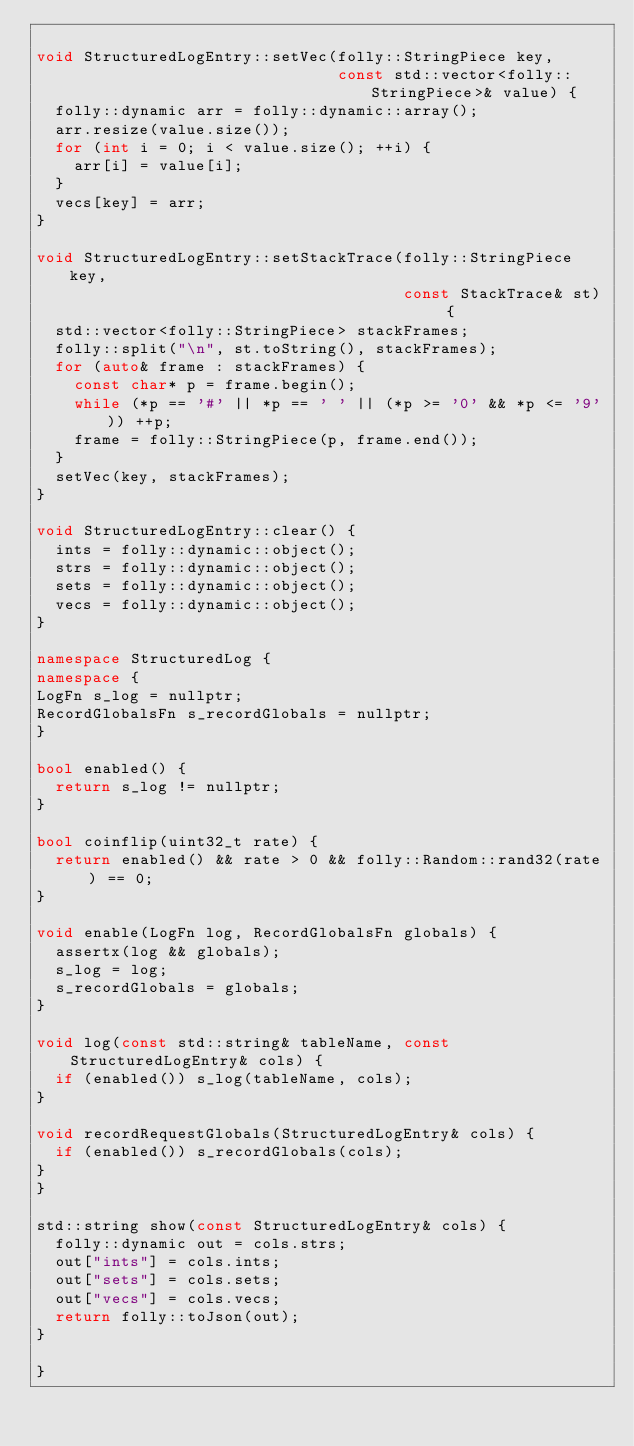<code> <loc_0><loc_0><loc_500><loc_500><_C++_>
void StructuredLogEntry::setVec(folly::StringPiece key,
                                const std::vector<folly::StringPiece>& value) {
  folly::dynamic arr = folly::dynamic::array();
  arr.resize(value.size());
  for (int i = 0; i < value.size(); ++i) {
    arr[i] = value[i];
  }
  vecs[key] = arr;
}

void StructuredLogEntry::setStackTrace(folly::StringPiece key,
                                       const StackTrace& st) {
  std::vector<folly::StringPiece> stackFrames;
  folly::split("\n", st.toString(), stackFrames);
  for (auto& frame : stackFrames) {
    const char* p = frame.begin();
    while (*p == '#' || *p == ' ' || (*p >= '0' && *p <= '9')) ++p;
    frame = folly::StringPiece(p, frame.end());
  }
  setVec(key, stackFrames);
}

void StructuredLogEntry::clear() {
  ints = folly::dynamic::object();
  strs = folly::dynamic::object();
  sets = folly::dynamic::object();
  vecs = folly::dynamic::object();
}

namespace StructuredLog {
namespace {
LogFn s_log = nullptr;
RecordGlobalsFn s_recordGlobals = nullptr;
}

bool enabled() {
  return s_log != nullptr;
}

bool coinflip(uint32_t rate) {
  return enabled() && rate > 0 && folly::Random::rand32(rate) == 0;
}

void enable(LogFn log, RecordGlobalsFn globals) {
  assertx(log && globals);
  s_log = log;
  s_recordGlobals = globals;
}

void log(const std::string& tableName, const StructuredLogEntry& cols) {
  if (enabled()) s_log(tableName, cols);
}

void recordRequestGlobals(StructuredLogEntry& cols) {
  if (enabled()) s_recordGlobals(cols);
}
}

std::string show(const StructuredLogEntry& cols) {
  folly::dynamic out = cols.strs;
  out["ints"] = cols.ints;
  out["sets"] = cols.sets;
  out["vecs"] = cols.vecs;
  return folly::toJson(out);
}

}
</code> 